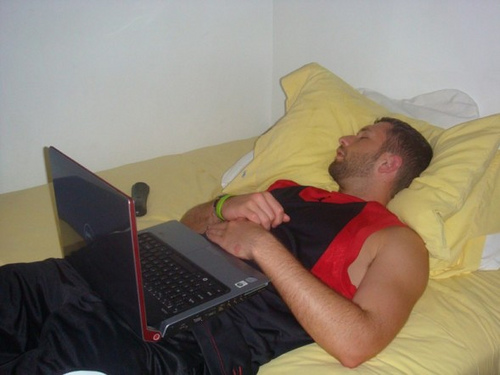Write a long, realistic scenario based on the image. Michael had spent the entire day juggling his responsibilities. After an early morning class, he had rushed to the library to finish a report that had a tight deadline. His part-time job at the campus gym kept him busy in the afternoon, training students and ensuring equipment was in order. By the evening, he was ready for some downtime. He came home, had a quick shower, and threw on his favorite black and red sportswear. Determined to finish his research, he powered up his laptop and propped himself against the pillows. The soft glow of the screen illuminated his determined expression as he typed away, sifting through articles and videos. Gradually, his eyelids grew heavy. He powered through, replaying a video for the third time, his concentration flagging. Without realizing it, his fingers stilled on the keyboard, his head lolled back, and soon, quiet snores filled the room. The remote control he had intended to use to switch to some light entertainment lay forgotten by his side. The room, now silent, cradled him in its familiar comfort, a peaceful end to a relentlessly productive day. 